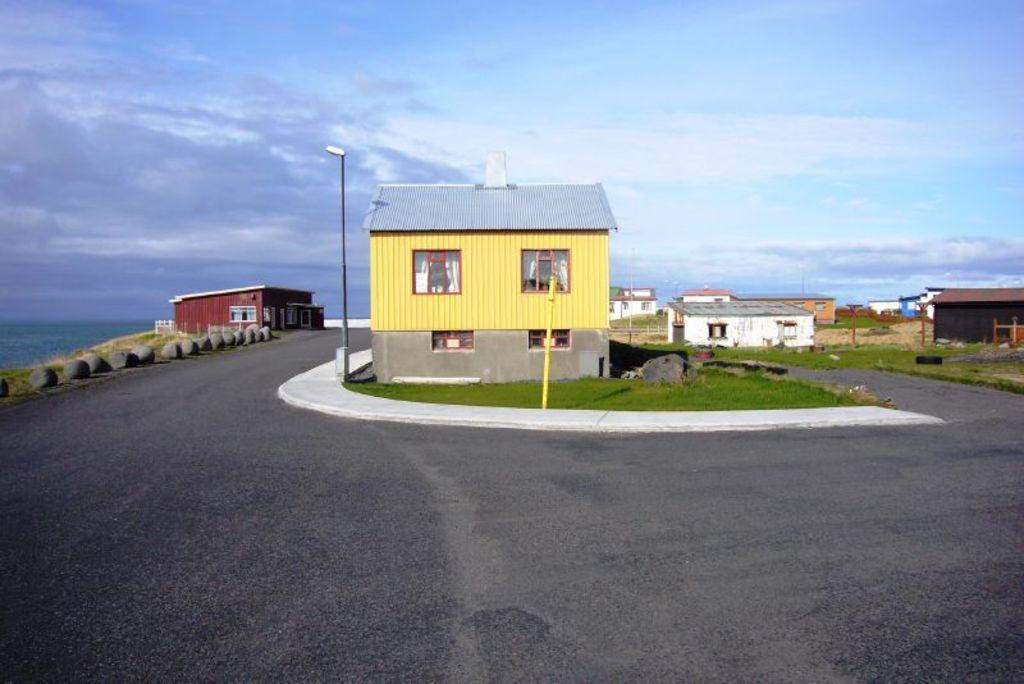Could you give a brief overview of what you see in this image? In this image I can see the road. In the background I can see the houses, poles and the grass. To the left I can see the rocks. In the background I can see the water, clouds and the sky. 